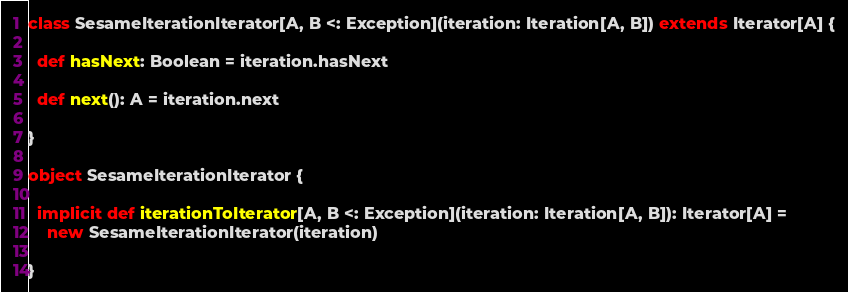<code> <loc_0><loc_0><loc_500><loc_500><_Scala_>class SesameIterationIterator[A, B <: Exception](iteration: Iteration[A, B]) extends Iterator[A] {

  def hasNext: Boolean = iteration.hasNext

  def next(): A = iteration.next

}

object SesameIterationIterator {

  implicit def iterationToIterator[A, B <: Exception](iteration: Iteration[A, B]): Iterator[A] =
    new SesameIterationIterator(iteration)

}
</code> 